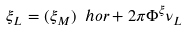Convert formula to latex. <formula><loc_0><loc_0><loc_500><loc_500>\xi _ { L } = ( \xi _ { M } ) \ h o r + 2 \pi \Phi ^ { \xi } \nu _ { L }</formula> 